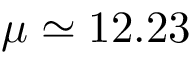Convert formula to latex. <formula><loc_0><loc_0><loc_500><loc_500>\mu \simeq 1 2 . 2 3</formula> 